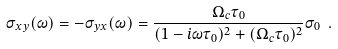Convert formula to latex. <formula><loc_0><loc_0><loc_500><loc_500>\sigma _ { x y } ( \omega ) = - \sigma _ { y x } ( \omega ) = \frac { \Omega _ { c } \tau _ { 0 } } { ( 1 - i \omega \tau _ { 0 } ) ^ { 2 } + ( \Omega _ { c } \tau _ { 0 } ) ^ { 2 } } \sigma _ { 0 } \ .</formula> 